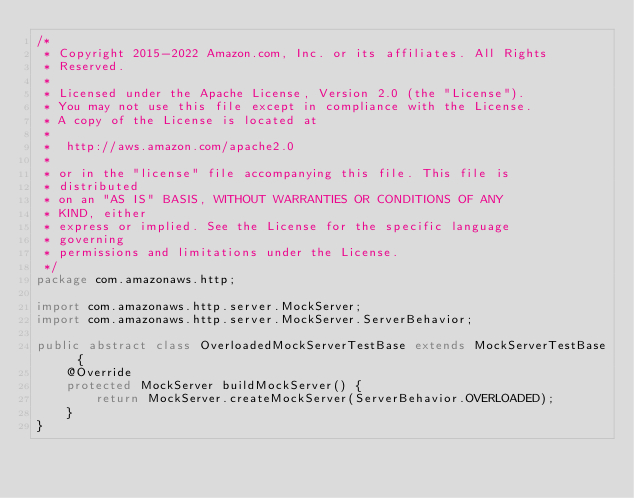Convert code to text. <code><loc_0><loc_0><loc_500><loc_500><_Java_>/*
 * Copyright 2015-2022 Amazon.com, Inc. or its affiliates. All Rights
 * Reserved.
 *
 * Licensed under the Apache License, Version 2.0 (the "License").
 * You may not use this file except in compliance with the License.
 * A copy of the License is located at
 *
 *  http://aws.amazon.com/apache2.0
 *
 * or in the "license" file accompanying this file. This file is
 * distributed
 * on an "AS IS" BASIS, WITHOUT WARRANTIES OR CONDITIONS OF ANY
 * KIND, either
 * express or implied. See the License for the specific language
 * governing
 * permissions and limitations under the License.
 */
package com.amazonaws.http;

import com.amazonaws.http.server.MockServer;
import com.amazonaws.http.server.MockServer.ServerBehavior;

public abstract class OverloadedMockServerTestBase extends MockServerTestBase {
    @Override
    protected MockServer buildMockServer() {
        return MockServer.createMockServer(ServerBehavior.OVERLOADED);
    }
}</code> 